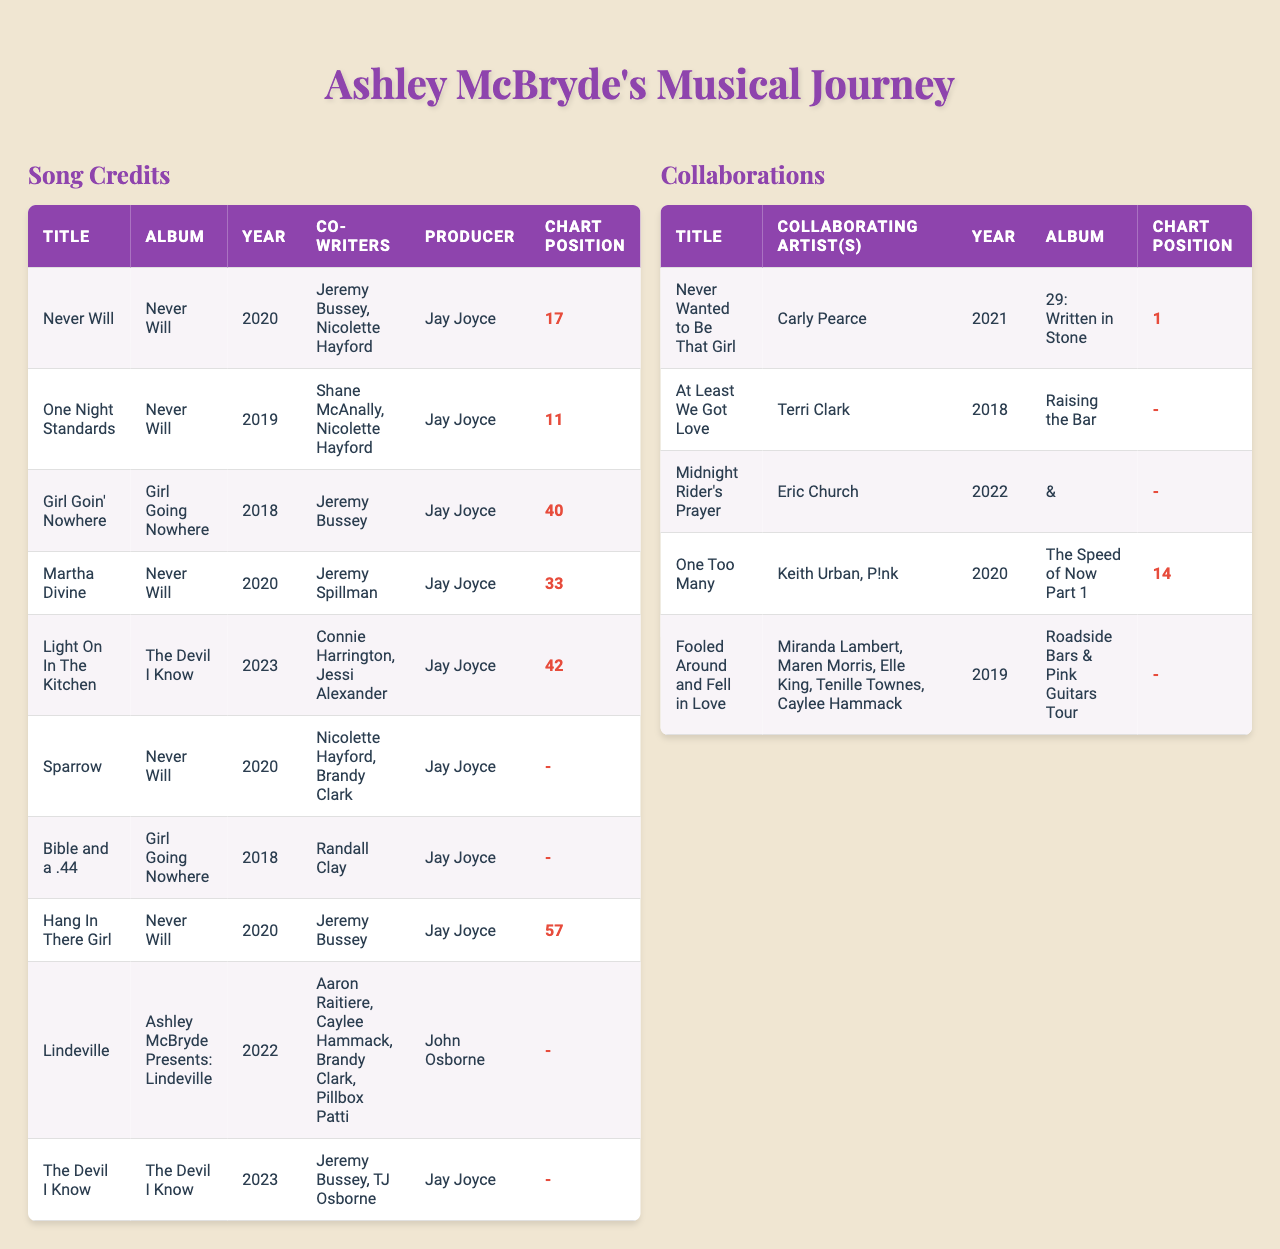What is the title of Ashley McBryde's song that reached the highest chart position in the US country charts? The song "Never Wanted to Be That Girl" featuring Carly Pearce reached chart position 1, which is the highest in the provided data.
Answer: Never Wanted to Be That Girl How many songs from the album "Never Will" are listed in the table? The table includes four songs from the album "Never Will": "Never Will," "One Night Standards," "Martha Divine," and "Hang In There Girl."
Answer: 4 Which song features the most co-writers? The song "Lindeville" features four co-writers: Aaron Raitiere, Caylee Hammack, Brandy Clark, and Pillbox Patti.
Answer: Lindeville What was the chart position for "One Night Standards"? The chart position for "One Night Standards" is 11 on the US country charts.
Answer: 11 Is there any song listed without a specific chart position? Yes, several songs have a chart position listed as null, including "Sparrow," "Bible and a .44," and "Lindeville."
Answer: Yes What is the average chart position of Ashley McBryde's songs listed in the table that have a defined chart position? The defined chart positions are 17, 11, 40, 33, 42, 57, and 1 from the collaborations. The average is (17 + 11 + 40 + 33 + 42 + 57 + 1) / 6 = 33.5.
Answer: 33.5 Which collaborating artist has a song that achieved a chart position of 14? Keith Urban and P!nk collaborated with Ashley McBryde on the song "One Too Many," which reached chart position 14.
Answer: Keith Urban, P!nk What year did Ashley McBryde release the song "Girl Goin' Nowhere"? The song "Girl Goin' Nowhere" was released in the year 2018.
Answer: 2018 Which song released in 2023 has the most co-writers, and who are they? The song "The Devil I Know" released in 2023 has two co-writers: Jeremy Bussey and TJ Osborne.
Answer: The Devil I Know Which album features the collaboration titled "Fooled Around and Fell in Love"? The collaboration "Fooled Around and Fell in Love" is featured in the album "Roadside Bars & Pink Guitars Tour."
Answer: Roadside Bars & Pink Guitars Tour 